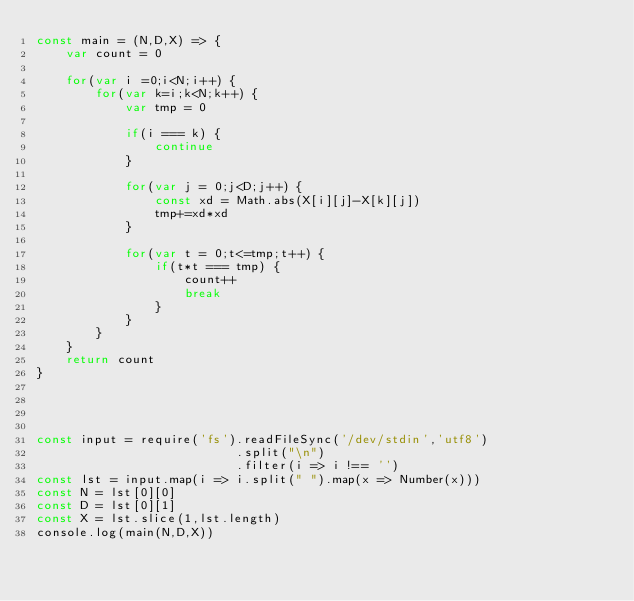Convert code to text. <code><loc_0><loc_0><loc_500><loc_500><_JavaScript_>const main = (N,D,X) => {
    var count = 0

    for(var i =0;i<N;i++) {
        for(var k=i;k<N;k++) {
            var tmp = 0

            if(i === k) {
                continue
            }

            for(var j = 0;j<D;j++) {
                const xd = Math.abs(X[i][j]-X[k][j])
                tmp+=xd*xd
            }

            for(var t = 0;t<=tmp;t++) {
                if(t*t === tmp) {
                    count++
                    break
                }
            }
        }
    }
    return count
}




const input = require('fs').readFileSync('/dev/stdin','utf8')
                           .split("\n")
                           .filter(i => i !== '')
const lst = input.map(i => i.split(" ").map(x => Number(x)))
const N = lst[0][0]
const D = lst[0][1]
const X = lst.slice(1,lst.length)
console.log(main(N,D,X))</code> 